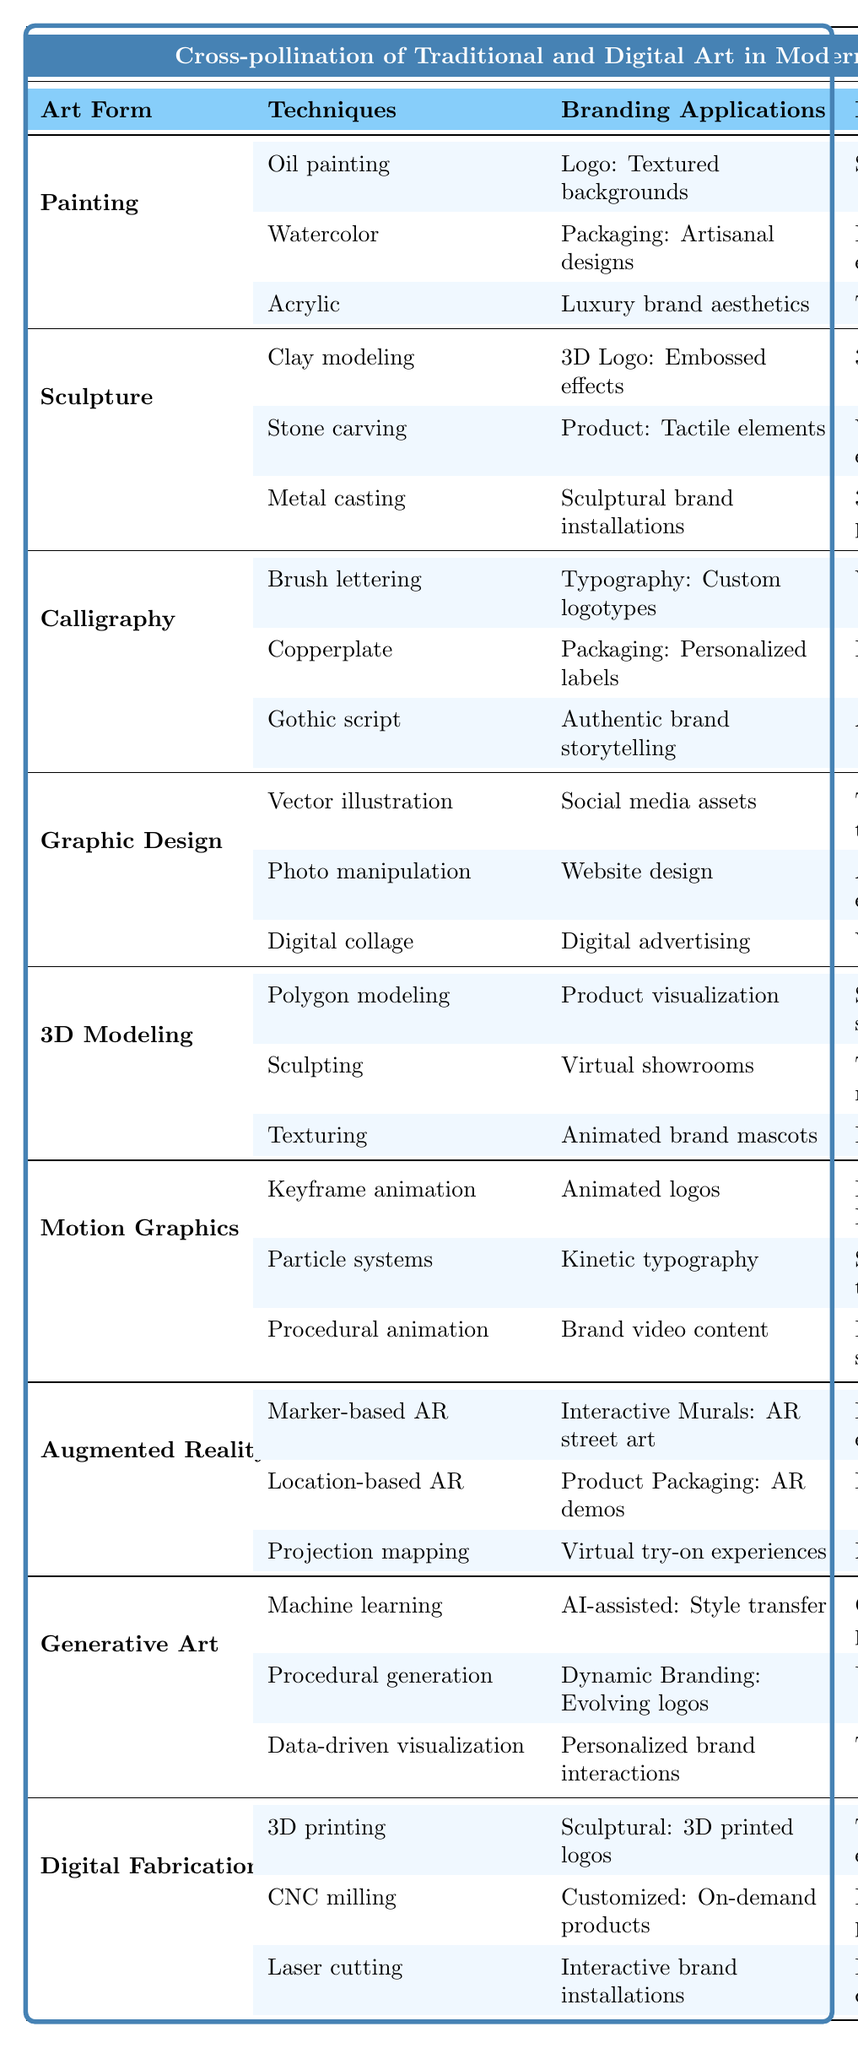What are the branding applications for Painting? The table lists three branding applications: logo design with textured backgrounds, packaging with artisanal product packaging, and luxury brand aesthetics.
Answer: Logo design, packaging What traditional techniques influence Graphic Design? The table mentions that Graphic Design incorporates three traditional techniques: texture integration with scanned paper textures, analog aesthetics with film grain effects, and vintage color palettes.
Answer: Scanned paper textures, film grain effects, vintage color palettes Is there a connection between Sculpture and Augmented Reality? Yes, both art forms show a cross-pollination of techniques. Sculpture influences AR through interactive murals that can apply sculptural branding techniques.
Answer: Yes Which digital art form uses calligraphy techniques? The table indicates that Calligraphy influences Digital Art Forms; specifically, it is applied in typography and packaging within Graphic Design.
Answer: Graphic Design What is the main impact of Digital Fabrication on branding? The table states that Digital Fabrication contributes tangible brand experiences and bridges the digital and physical realms, indicating its overall branding impact.
Answer: Tangible brand experiences, bridging digital and physical What branding applications are linked to Motion Graphics? The listed branding applications for Motion Graphics are animated logos, kinetic typography, and brand video content.
Answer: Animated logos, kinetic typography, brand video content Could you list the techniques used in 3D Modeling? According to the table, the techniques for 3D Modeling include polygon modeling, sculpting, and texturing.
Answer: Polygon modeling, sculpting, texturing Which hybrid approach incorporates machine learning? The hybrid approach of Generative Art involves machine learning algorithms as part of its foundational technology.
Answer: Generative Art What are the specific animation techniques used in Motion Graphics? The table outlines three animation techniques: keyframe animation, particle systems, and procedural animation.
Answer: Keyframe animation, particle systems, procedural animation Does Painting have any applications in sculpture design? No, Painting's applications do not overlap with sculpture design; rather, they are distinct and categorized separately in the table.
Answer: No 